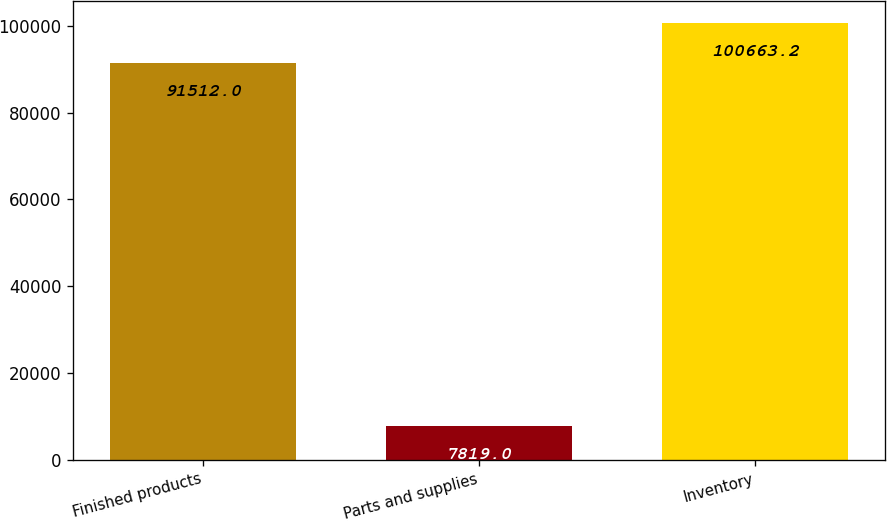Convert chart. <chart><loc_0><loc_0><loc_500><loc_500><bar_chart><fcel>Finished products<fcel>Parts and supplies<fcel>Inventory<nl><fcel>91512<fcel>7819<fcel>100663<nl></chart> 